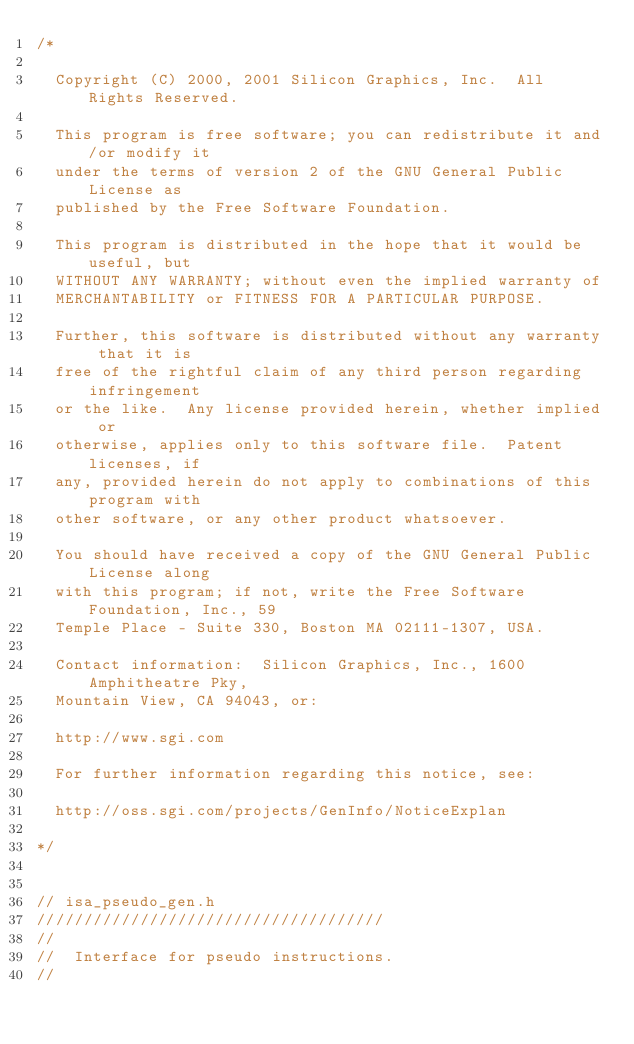<code> <loc_0><loc_0><loc_500><loc_500><_C_>/*

  Copyright (C) 2000, 2001 Silicon Graphics, Inc.  All Rights Reserved.

  This program is free software; you can redistribute it and/or modify it
  under the terms of version 2 of the GNU General Public License as
  published by the Free Software Foundation.

  This program is distributed in the hope that it would be useful, but
  WITHOUT ANY WARRANTY; without even the implied warranty of
  MERCHANTABILITY or FITNESS FOR A PARTICULAR PURPOSE.  

  Further, this software is distributed without any warranty that it is
  free of the rightful claim of any third person regarding infringement 
  or the like.  Any license provided herein, whether implied or 
  otherwise, applies only to this software file.  Patent licenses, if 
  any, provided herein do not apply to combinations of this program with 
  other software, or any other product whatsoever.  

  You should have received a copy of the GNU General Public License along
  with this program; if not, write the Free Software Foundation, Inc., 59
  Temple Place - Suite 330, Boston MA 02111-1307, USA.

  Contact information:  Silicon Graphics, Inc., 1600 Amphitheatre Pky,
  Mountain View, CA 94043, or:

  http://www.sgi.com

  For further information regarding this notice, see:

  http://oss.sgi.com/projects/GenInfo/NoticeExplan

*/


// isa_pseudo_gen.h
/////////////////////////////////////
//
//  Interface for pseudo instructions.
//</code> 